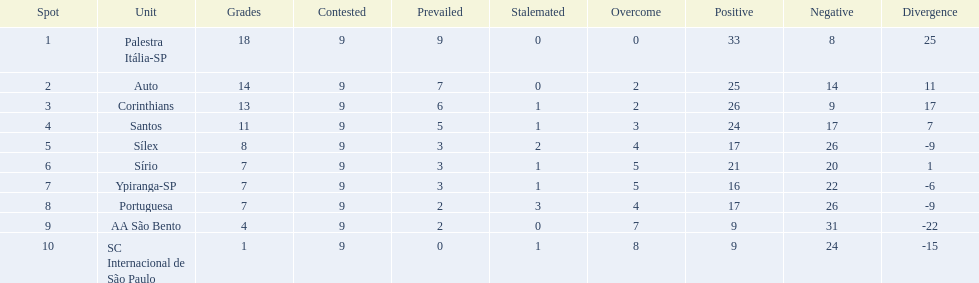How many points were scored by the teams? 18, 14, 13, 11, 8, 7, 7, 7, 4, 1. What team scored 13 points? Corinthians. 